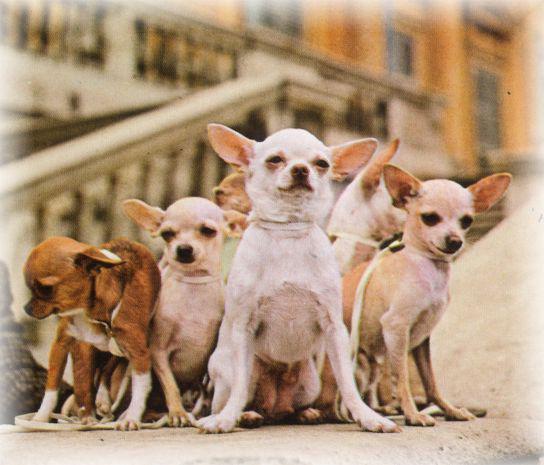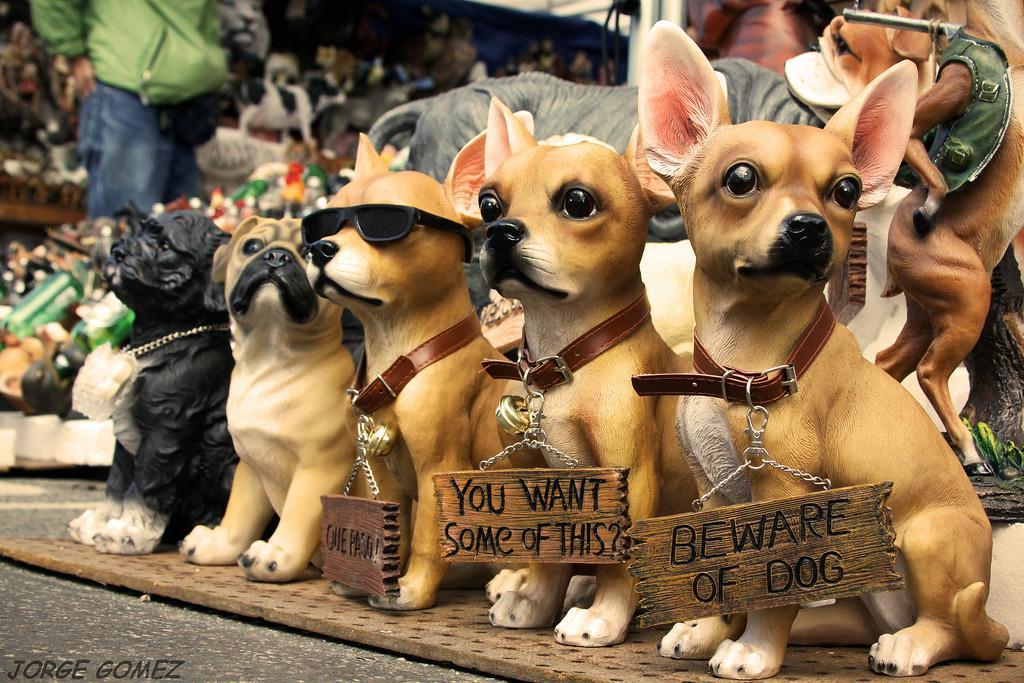The first image is the image on the left, the second image is the image on the right. Assess this claim about the two images: "At least one of the images contains only one chihuahuas.". Correct or not? Answer yes or no. No. The first image is the image on the left, the second image is the image on the right. For the images displayed, is the sentence "In at least one image, there is only one dog." factually correct? Answer yes or no. No. 